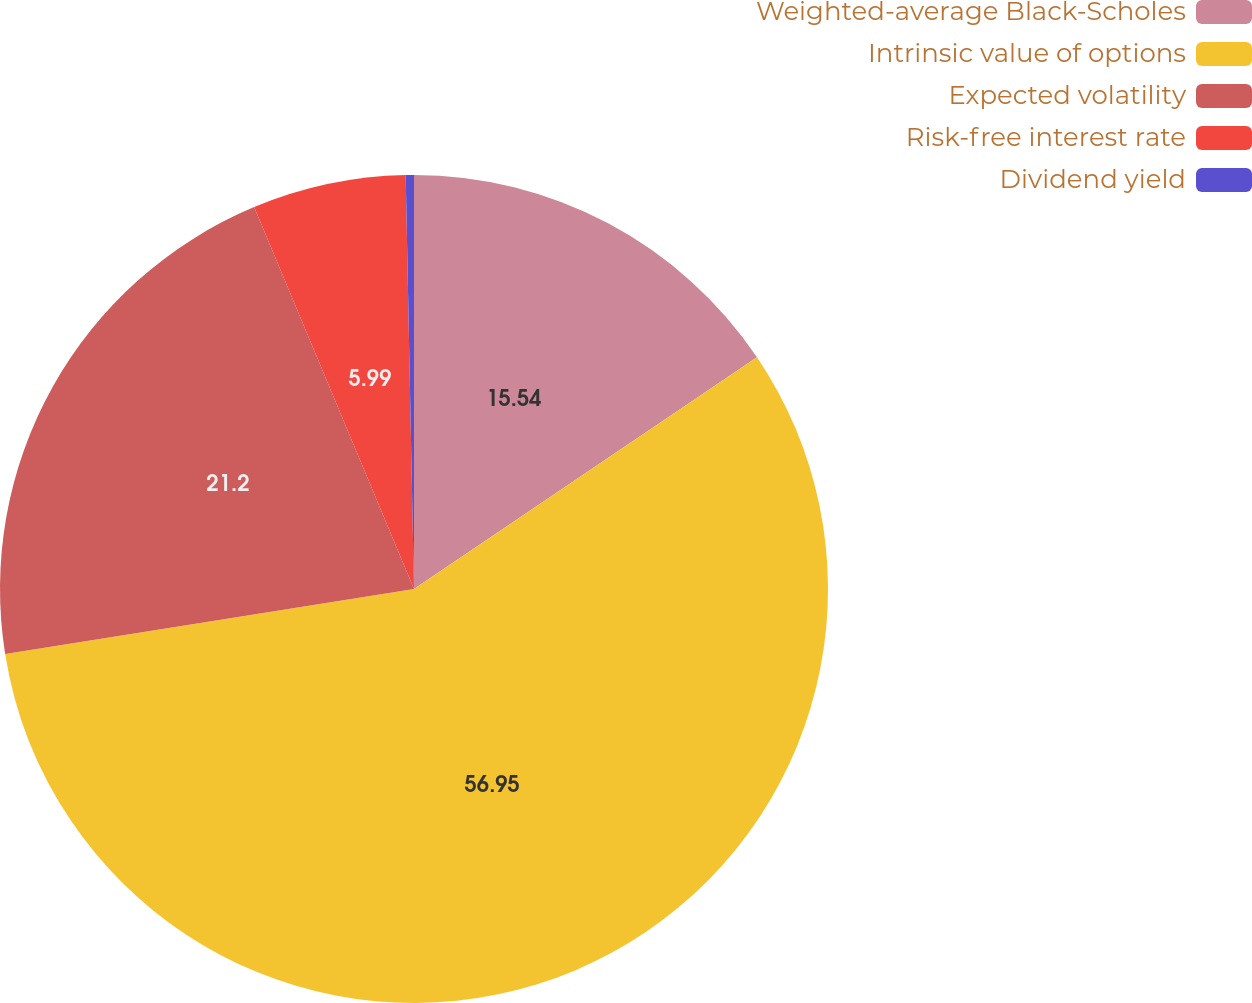Convert chart to OTSL. <chart><loc_0><loc_0><loc_500><loc_500><pie_chart><fcel>Weighted-average Black-Scholes<fcel>Intrinsic value of options<fcel>Expected volatility<fcel>Risk-free interest rate<fcel>Dividend yield<nl><fcel>15.54%<fcel>56.95%<fcel>21.2%<fcel>5.99%<fcel>0.32%<nl></chart> 